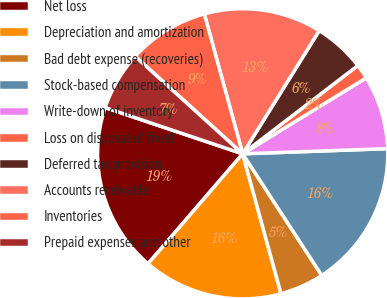Convert chart. <chart><loc_0><loc_0><loc_500><loc_500><pie_chart><fcel>Net loss<fcel>Depreciation and amortization<fcel>Bad debt expense (recoveries)<fcel>Stock-based compensation<fcel>Write-down of inventory<fcel>Loss on disposal of fixed<fcel>Deferred tax provision<fcel>Accounts receivable<fcel>Inventories<fcel>Prepaid expenses and other<nl><fcel>18.85%<fcel>15.57%<fcel>4.92%<fcel>16.39%<fcel>8.2%<fcel>1.64%<fcel>5.74%<fcel>13.11%<fcel>9.02%<fcel>6.56%<nl></chart> 